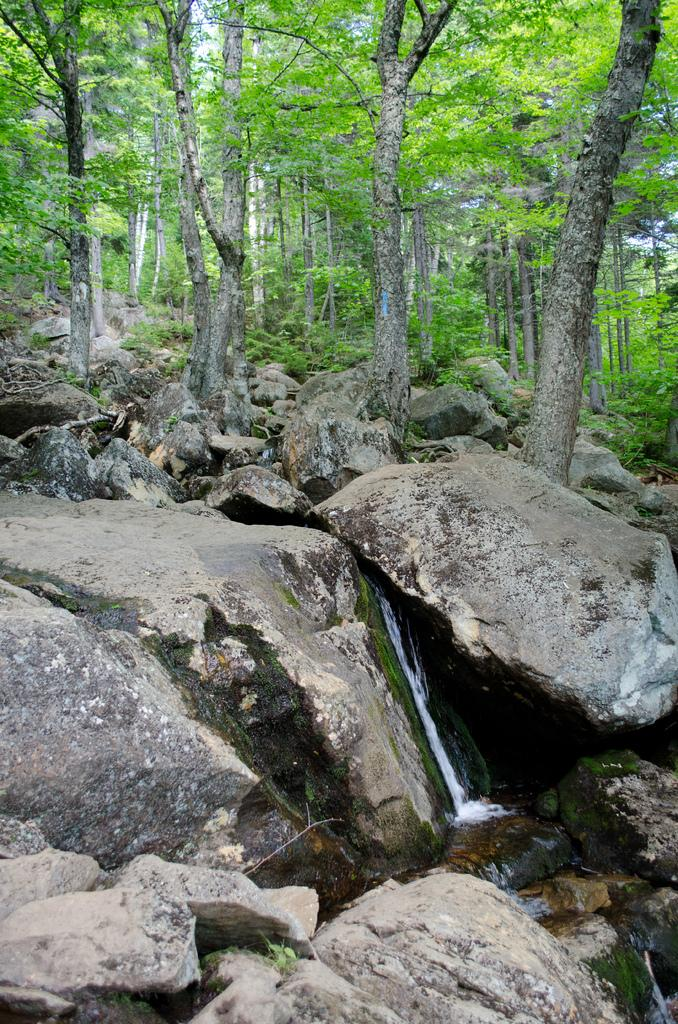What type of natural environment is depicted in the image? The image appears to depict a forest. What can be seen at the bottom of the image? There are many rocks and water visible at the bottom of the image. What is visible in the background of the image? There are many trees in the background of the image. What color is the dress worn by the tree in the image? There are no trees wearing dresses in the image; trees do not wear clothing. 